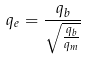<formula> <loc_0><loc_0><loc_500><loc_500>q _ { e } = \frac { q _ { b } } { \sqrt { \frac { q _ { b } } { q _ { m } } } }</formula> 